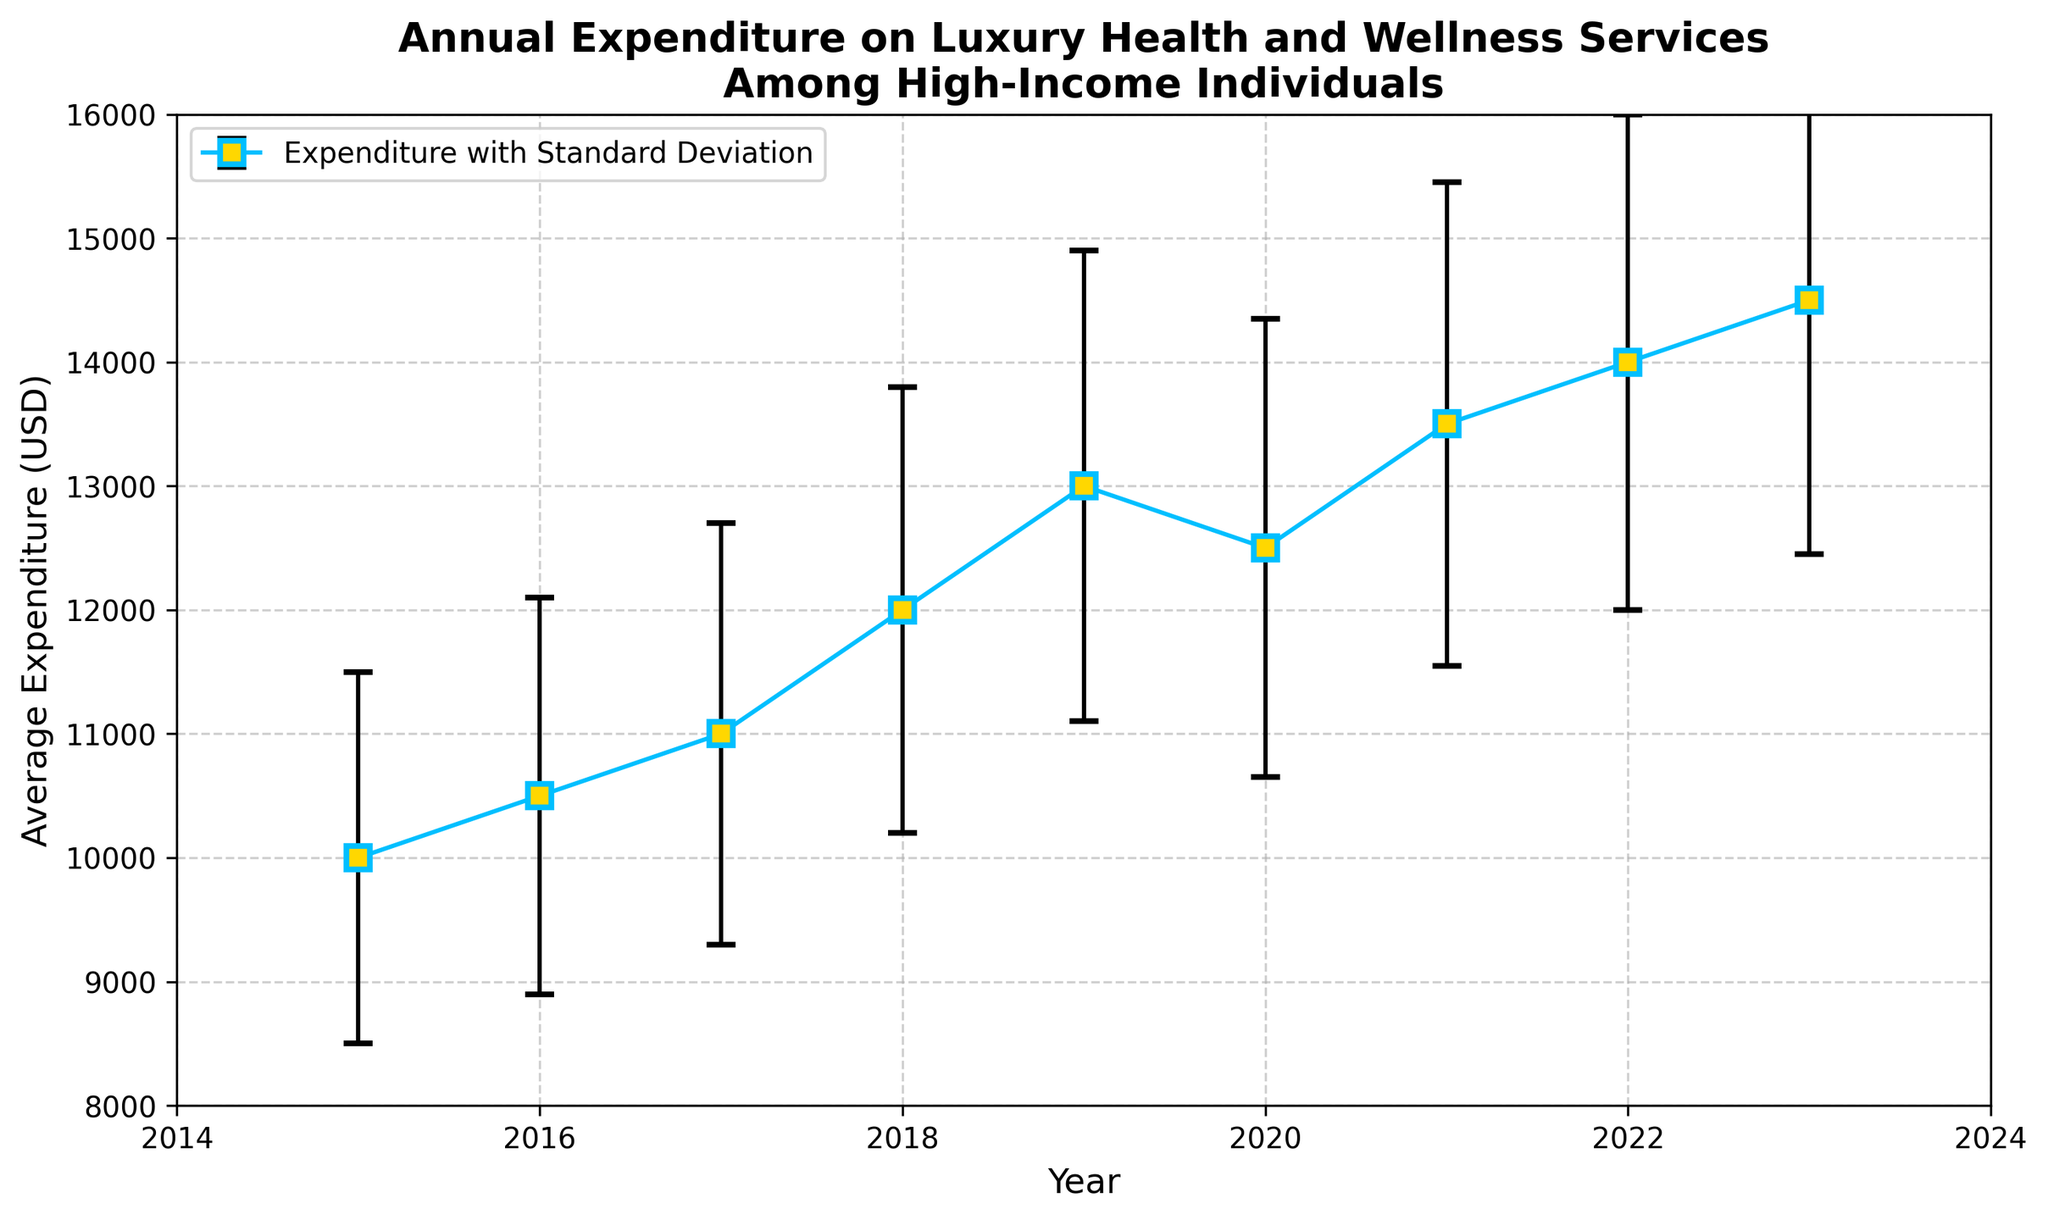What is the average expenditure for the year 2017? To find the average expenditure for 2017, look at the data point labeled "2017" on the X-axis and read the corresponding Y-axis value.
Answer: 11,000 USD Did the average expenditure increase or decrease between 2019 and 2020? Compare the Y-axis values of the data points labeled "2019" and "2020." The average expenditure decreased from 13,000 USD in 2019 to 12,500 USD in 2020.
Answer: Decrease What is the range of the standard deviation values from 2015 to 2023? Identify the standard deviation values for each year from the data table and calculate the range: max - min. The highest standard deviation is 2050 (2023) and the lowest is 1500 (2015). 2050 - 1500 = 550
Answer: 550 USD Between which two consecutive years was the increase in average expenditure the highest? Examine the differences in average expenditure between each consecutive year and identify the largest increase. The largest increase was from 2018 (12,000 USD) to 2019 (13,000 USD), a difference of 1,000 USD.
Answer: 2018 to 2019 What was the overall trend in average expenditure from 2015 to 2023? Evaluate the general direction of the data points on the Y-axis from 2015 to 2023. The overall trend shows a gradual increase in average expenditure over the years.
Answer: Gradual increase Which year had the highest standard deviation in expenditure? Refer to the legend showing standard deviation values and identify the highest one. The highest standard deviation value is 2050 USD, which corresponds to the year 2023.
Answer: 2023 How does the average expenditure in 2021 compare to that in 2023? Compare the Y-axis values for the data points labeled "2021" and "2023." Expenditure in 2021 was 13,500 USD while in 2023 it was 14,500 USD.
Answer: 2023 is higher by 1,000 USD In which year was the average expenditure closest to 12,000 USD? Identify the data point on the Y-axis that is nearest to 12,000 USD. In 2018, the average expenditure was exactly 12,000 USD.
Answer: 2018 What is the difference in average expenditure between 2015 and 2023? Calculate the difference between the Y-axis values for 2015 and 2023. The expenditure in 2015 was 10,000 USD and in 2023 it was 14,500 USD, making the difference 14,500 - 10,000 = 4,500 USD.
Answer: 4,500 USD 